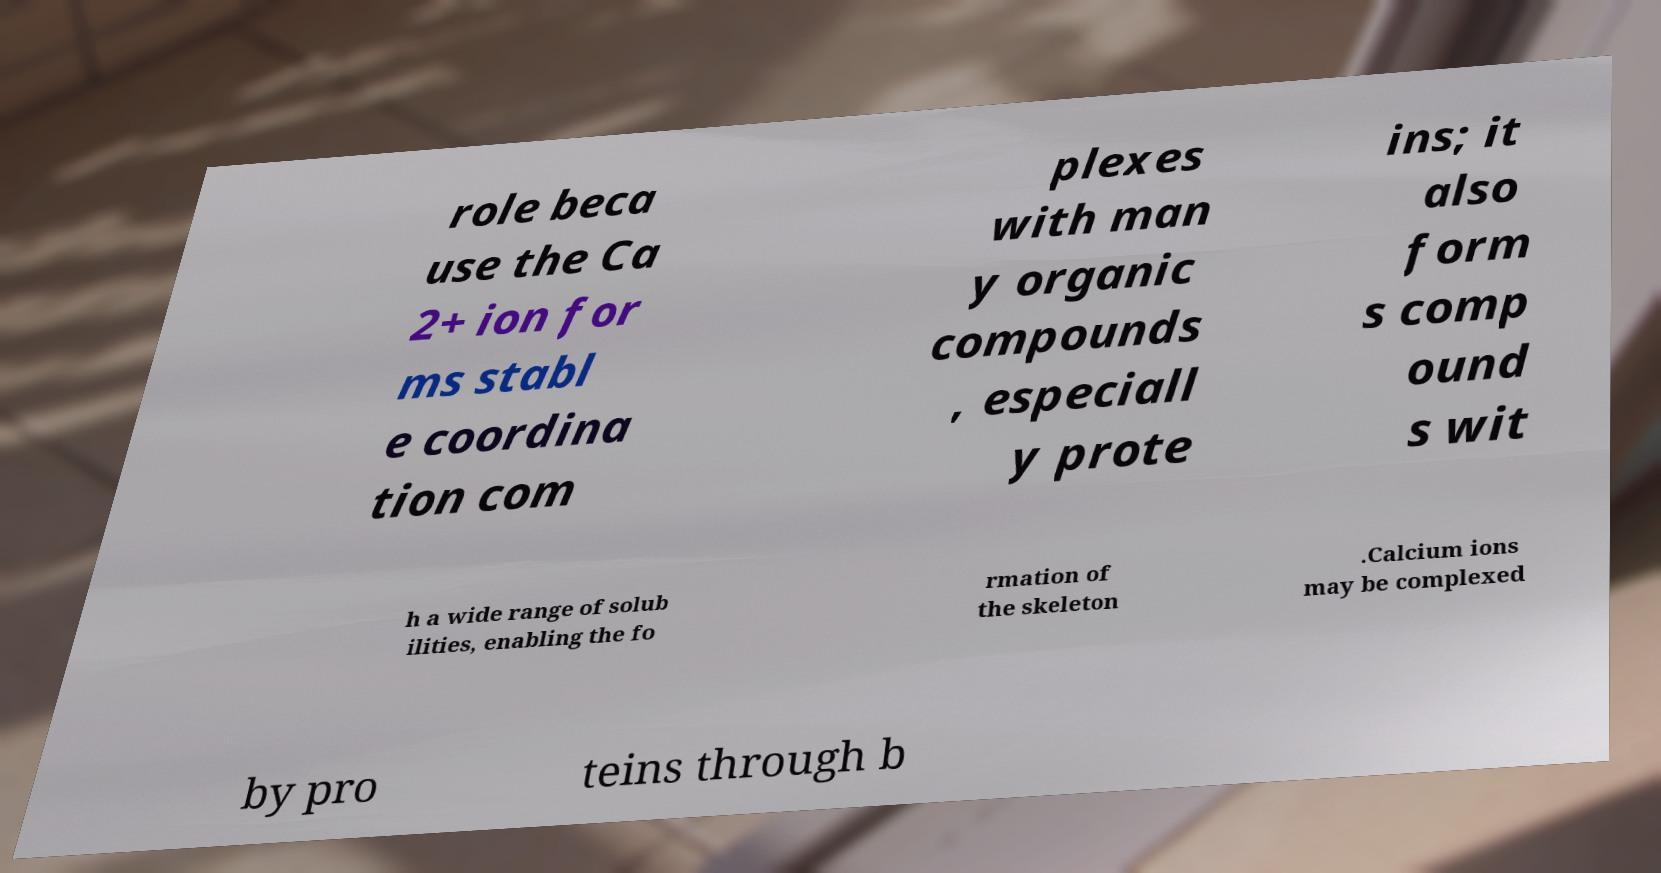Can you accurately transcribe the text from the provided image for me? role beca use the Ca 2+ ion for ms stabl e coordina tion com plexes with man y organic compounds , especiall y prote ins; it also form s comp ound s wit h a wide range of solub ilities, enabling the fo rmation of the skeleton .Calcium ions may be complexed by pro teins through b 